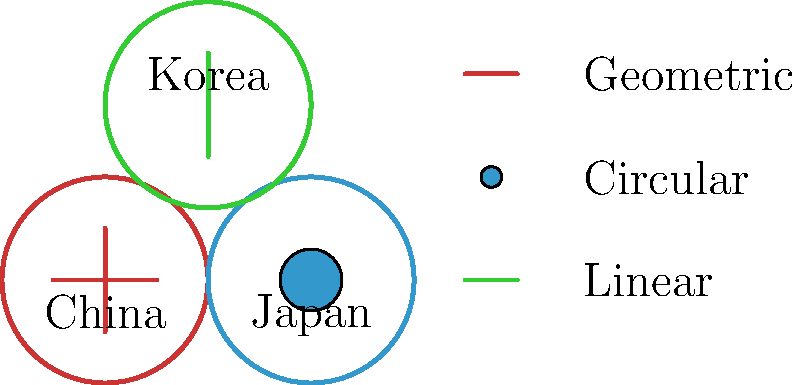Analyze the symbolic elements represented in the diagram for antique maps from China, Japan, and Korea. Which culture's cartographic tradition tends to emphasize circular motifs, and how does this reflect their worldview compared to the other two cultures shown? 1. Examine the symbolic elements for each culture:
   - China: Intersecting lines forming a cross
   - Japan: Solid circle
   - Korea: Single vertical line

2. Identify the culture emphasizing circular motifs:
   Japan is represented by a solid circle, indicating a strong emphasis on circular symbols in their cartographic tradition.

3. Compare Japanese circular motifs to other cultures:
   - China's intersecting lines suggest a focus on cardinal directions and a grid-like worldview.
   - Korea's single line may represent a more linear or axial perspective.

4. Interpret the significance of circular motifs in Japanese cartography:
   - Circles often symbolize completeness, unity, and harmony in East Asian philosophy.
   - In Japanese culture, this could reflect a view of the world as interconnected and cyclical.
   - It may also relate to the island nature of Japan, surrounded by ocean.

5. Consider historical and cultural contexts:
   - Japanese maps often depicted their islands at the center of concentric circles representing the world.
   - This circular representation aligns with Buddhist cosmology and the concept of mandala.

6. Contrast with Chinese and Korean symbolism:
   - Chinese cross-like symbol suggests a more structured, hierarchical worldview.
   - Korean linear symbol might indicate a focus on continuity or a peninsula-influenced perspective.

7. Conclude how Japanese circular motifs reflect their unique worldview:
   The emphasis on circular elements in Japanese antique maps reflects a holistic, cyclical understanding of the world, distinct from the more directional or linear perspectives of neighboring cultures.
Answer: Japan; circular motifs reflect a holistic, cyclical worldview. 